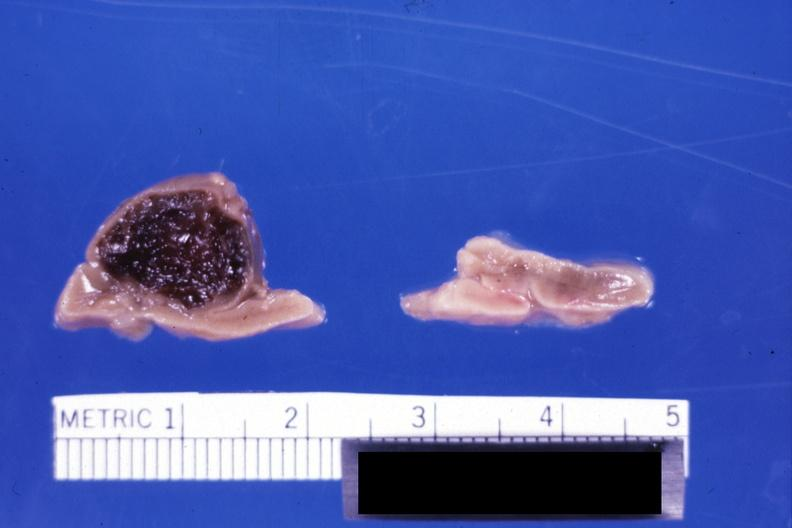does this image show fixed tissue but not bad color stillborn infant maternal sepsis e coli hemorrhaged into peritoneum?
Answer the question using a single word or phrase. Yes 